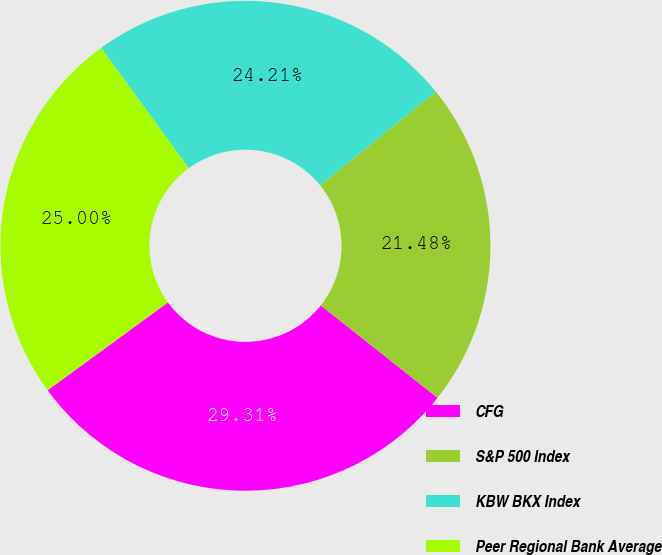Convert chart. <chart><loc_0><loc_0><loc_500><loc_500><pie_chart><fcel>CFG<fcel>S&P 500 Index<fcel>KBW BKX Index<fcel>Peer Regional Bank Average<nl><fcel>29.31%<fcel>21.48%<fcel>24.21%<fcel>25.0%<nl></chart> 